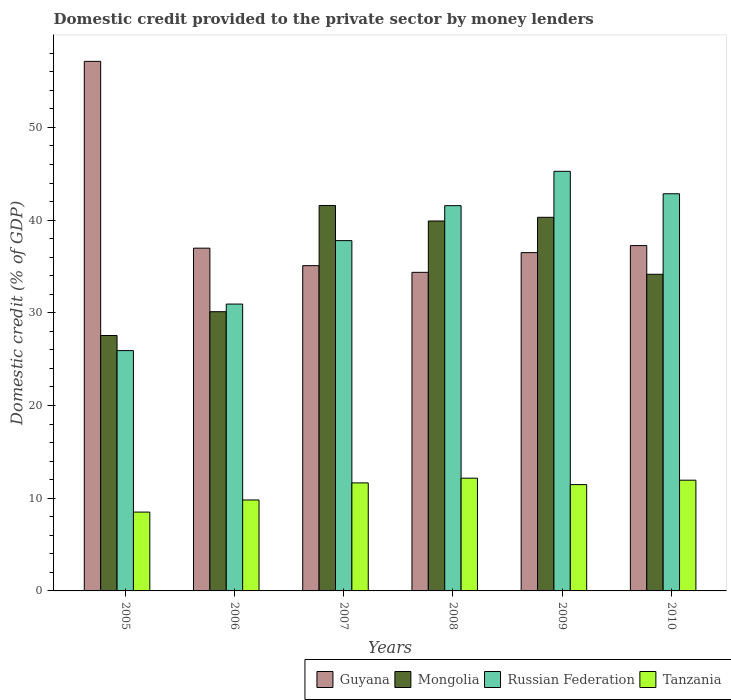Are the number of bars per tick equal to the number of legend labels?
Make the answer very short. Yes. Are the number of bars on each tick of the X-axis equal?
Give a very brief answer. Yes. What is the label of the 6th group of bars from the left?
Ensure brevity in your answer.  2010. What is the domestic credit provided to the private sector by money lenders in Mongolia in 2008?
Offer a very short reply. 39.9. Across all years, what is the maximum domestic credit provided to the private sector by money lenders in Mongolia?
Your response must be concise. 41.58. Across all years, what is the minimum domestic credit provided to the private sector by money lenders in Tanzania?
Your answer should be compact. 8.5. In which year was the domestic credit provided to the private sector by money lenders in Mongolia maximum?
Your answer should be compact. 2007. What is the total domestic credit provided to the private sector by money lenders in Russian Federation in the graph?
Offer a terse response. 224.3. What is the difference between the domestic credit provided to the private sector by money lenders in Tanzania in 2006 and that in 2009?
Make the answer very short. -1.66. What is the difference between the domestic credit provided to the private sector by money lenders in Guyana in 2008 and the domestic credit provided to the private sector by money lenders in Mongolia in 2005?
Offer a terse response. 6.81. What is the average domestic credit provided to the private sector by money lenders in Tanzania per year?
Give a very brief answer. 10.92. In the year 2007, what is the difference between the domestic credit provided to the private sector by money lenders in Russian Federation and domestic credit provided to the private sector by money lenders in Tanzania?
Give a very brief answer. 26.13. In how many years, is the domestic credit provided to the private sector by money lenders in Guyana greater than 10 %?
Give a very brief answer. 6. What is the ratio of the domestic credit provided to the private sector by money lenders in Russian Federation in 2008 to that in 2010?
Keep it short and to the point. 0.97. Is the domestic credit provided to the private sector by money lenders in Russian Federation in 2005 less than that in 2007?
Provide a succinct answer. Yes. What is the difference between the highest and the second highest domestic credit provided to the private sector by money lenders in Tanzania?
Provide a short and direct response. 0.22. What is the difference between the highest and the lowest domestic credit provided to the private sector by money lenders in Mongolia?
Ensure brevity in your answer.  14.03. In how many years, is the domestic credit provided to the private sector by money lenders in Guyana greater than the average domestic credit provided to the private sector by money lenders in Guyana taken over all years?
Your answer should be compact. 1. What does the 3rd bar from the left in 2010 represents?
Ensure brevity in your answer.  Russian Federation. What does the 1st bar from the right in 2008 represents?
Provide a succinct answer. Tanzania. How many bars are there?
Ensure brevity in your answer.  24. How many legend labels are there?
Offer a very short reply. 4. How are the legend labels stacked?
Your answer should be very brief. Horizontal. What is the title of the graph?
Provide a succinct answer. Domestic credit provided to the private sector by money lenders. Does "Armenia" appear as one of the legend labels in the graph?
Ensure brevity in your answer.  No. What is the label or title of the X-axis?
Make the answer very short. Years. What is the label or title of the Y-axis?
Offer a terse response. Domestic credit (% of GDP). What is the Domestic credit (% of GDP) of Guyana in 2005?
Your answer should be very brief. 57.12. What is the Domestic credit (% of GDP) in Mongolia in 2005?
Provide a short and direct response. 27.55. What is the Domestic credit (% of GDP) of Russian Federation in 2005?
Keep it short and to the point. 25.92. What is the Domestic credit (% of GDP) in Tanzania in 2005?
Provide a succinct answer. 8.5. What is the Domestic credit (% of GDP) of Guyana in 2006?
Give a very brief answer. 36.97. What is the Domestic credit (% of GDP) in Mongolia in 2006?
Offer a terse response. 30.12. What is the Domestic credit (% of GDP) in Russian Federation in 2006?
Provide a succinct answer. 30.94. What is the Domestic credit (% of GDP) of Tanzania in 2006?
Your answer should be compact. 9.81. What is the Domestic credit (% of GDP) of Guyana in 2007?
Ensure brevity in your answer.  35.08. What is the Domestic credit (% of GDP) of Mongolia in 2007?
Offer a terse response. 41.58. What is the Domestic credit (% of GDP) in Russian Federation in 2007?
Offer a terse response. 37.78. What is the Domestic credit (% of GDP) in Tanzania in 2007?
Your answer should be compact. 11.65. What is the Domestic credit (% of GDP) of Guyana in 2008?
Provide a short and direct response. 34.36. What is the Domestic credit (% of GDP) in Mongolia in 2008?
Provide a succinct answer. 39.9. What is the Domestic credit (% of GDP) in Russian Federation in 2008?
Ensure brevity in your answer.  41.55. What is the Domestic credit (% of GDP) in Tanzania in 2008?
Offer a very short reply. 12.16. What is the Domestic credit (% of GDP) in Guyana in 2009?
Keep it short and to the point. 36.49. What is the Domestic credit (% of GDP) of Mongolia in 2009?
Your response must be concise. 40.3. What is the Domestic credit (% of GDP) of Russian Federation in 2009?
Ensure brevity in your answer.  45.26. What is the Domestic credit (% of GDP) in Tanzania in 2009?
Keep it short and to the point. 11.47. What is the Domestic credit (% of GDP) of Guyana in 2010?
Your response must be concise. 37.25. What is the Domestic credit (% of GDP) in Mongolia in 2010?
Give a very brief answer. 34.16. What is the Domestic credit (% of GDP) in Russian Federation in 2010?
Your response must be concise. 42.84. What is the Domestic credit (% of GDP) in Tanzania in 2010?
Provide a succinct answer. 11.94. Across all years, what is the maximum Domestic credit (% of GDP) of Guyana?
Ensure brevity in your answer.  57.12. Across all years, what is the maximum Domestic credit (% of GDP) of Mongolia?
Keep it short and to the point. 41.58. Across all years, what is the maximum Domestic credit (% of GDP) in Russian Federation?
Keep it short and to the point. 45.26. Across all years, what is the maximum Domestic credit (% of GDP) in Tanzania?
Give a very brief answer. 12.16. Across all years, what is the minimum Domestic credit (% of GDP) in Guyana?
Offer a terse response. 34.36. Across all years, what is the minimum Domestic credit (% of GDP) in Mongolia?
Provide a short and direct response. 27.55. Across all years, what is the minimum Domestic credit (% of GDP) in Russian Federation?
Offer a terse response. 25.92. Across all years, what is the minimum Domestic credit (% of GDP) in Tanzania?
Make the answer very short. 8.5. What is the total Domestic credit (% of GDP) of Guyana in the graph?
Offer a very short reply. 237.28. What is the total Domestic credit (% of GDP) in Mongolia in the graph?
Provide a short and direct response. 213.6. What is the total Domestic credit (% of GDP) in Russian Federation in the graph?
Offer a terse response. 224.3. What is the total Domestic credit (% of GDP) in Tanzania in the graph?
Keep it short and to the point. 65.54. What is the difference between the Domestic credit (% of GDP) of Guyana in 2005 and that in 2006?
Offer a terse response. 20.15. What is the difference between the Domestic credit (% of GDP) of Mongolia in 2005 and that in 2006?
Give a very brief answer. -2.57. What is the difference between the Domestic credit (% of GDP) in Russian Federation in 2005 and that in 2006?
Offer a terse response. -5.02. What is the difference between the Domestic credit (% of GDP) in Tanzania in 2005 and that in 2006?
Give a very brief answer. -1.31. What is the difference between the Domestic credit (% of GDP) of Guyana in 2005 and that in 2007?
Offer a very short reply. 22.04. What is the difference between the Domestic credit (% of GDP) in Mongolia in 2005 and that in 2007?
Offer a very short reply. -14.03. What is the difference between the Domestic credit (% of GDP) in Russian Federation in 2005 and that in 2007?
Make the answer very short. -11.86. What is the difference between the Domestic credit (% of GDP) in Tanzania in 2005 and that in 2007?
Give a very brief answer. -3.15. What is the difference between the Domestic credit (% of GDP) of Guyana in 2005 and that in 2008?
Your response must be concise. 22.76. What is the difference between the Domestic credit (% of GDP) of Mongolia in 2005 and that in 2008?
Make the answer very short. -12.35. What is the difference between the Domestic credit (% of GDP) of Russian Federation in 2005 and that in 2008?
Give a very brief answer. -15.63. What is the difference between the Domestic credit (% of GDP) of Tanzania in 2005 and that in 2008?
Keep it short and to the point. -3.66. What is the difference between the Domestic credit (% of GDP) in Guyana in 2005 and that in 2009?
Your answer should be compact. 20.63. What is the difference between the Domestic credit (% of GDP) of Mongolia in 2005 and that in 2009?
Ensure brevity in your answer.  -12.75. What is the difference between the Domestic credit (% of GDP) in Russian Federation in 2005 and that in 2009?
Offer a terse response. -19.34. What is the difference between the Domestic credit (% of GDP) in Tanzania in 2005 and that in 2009?
Give a very brief answer. -2.96. What is the difference between the Domestic credit (% of GDP) of Guyana in 2005 and that in 2010?
Your answer should be very brief. 19.87. What is the difference between the Domestic credit (% of GDP) in Mongolia in 2005 and that in 2010?
Give a very brief answer. -6.61. What is the difference between the Domestic credit (% of GDP) of Russian Federation in 2005 and that in 2010?
Offer a terse response. -16.92. What is the difference between the Domestic credit (% of GDP) of Tanzania in 2005 and that in 2010?
Offer a terse response. -3.44. What is the difference between the Domestic credit (% of GDP) in Guyana in 2006 and that in 2007?
Your response must be concise. 1.89. What is the difference between the Domestic credit (% of GDP) in Mongolia in 2006 and that in 2007?
Your response must be concise. -11.46. What is the difference between the Domestic credit (% of GDP) of Russian Federation in 2006 and that in 2007?
Give a very brief answer. -6.84. What is the difference between the Domestic credit (% of GDP) in Tanzania in 2006 and that in 2007?
Offer a terse response. -1.84. What is the difference between the Domestic credit (% of GDP) of Guyana in 2006 and that in 2008?
Give a very brief answer. 2.61. What is the difference between the Domestic credit (% of GDP) in Mongolia in 2006 and that in 2008?
Make the answer very short. -9.78. What is the difference between the Domestic credit (% of GDP) of Russian Federation in 2006 and that in 2008?
Ensure brevity in your answer.  -10.61. What is the difference between the Domestic credit (% of GDP) of Tanzania in 2006 and that in 2008?
Your answer should be very brief. -2.35. What is the difference between the Domestic credit (% of GDP) in Guyana in 2006 and that in 2009?
Your answer should be very brief. 0.48. What is the difference between the Domestic credit (% of GDP) in Mongolia in 2006 and that in 2009?
Give a very brief answer. -10.18. What is the difference between the Domestic credit (% of GDP) of Russian Federation in 2006 and that in 2009?
Your response must be concise. -14.32. What is the difference between the Domestic credit (% of GDP) in Tanzania in 2006 and that in 2009?
Your response must be concise. -1.66. What is the difference between the Domestic credit (% of GDP) of Guyana in 2006 and that in 2010?
Your answer should be compact. -0.28. What is the difference between the Domestic credit (% of GDP) in Mongolia in 2006 and that in 2010?
Keep it short and to the point. -4.04. What is the difference between the Domestic credit (% of GDP) of Russian Federation in 2006 and that in 2010?
Ensure brevity in your answer.  -11.9. What is the difference between the Domestic credit (% of GDP) in Tanzania in 2006 and that in 2010?
Your response must be concise. -2.13. What is the difference between the Domestic credit (% of GDP) in Guyana in 2007 and that in 2008?
Offer a very short reply. 0.72. What is the difference between the Domestic credit (% of GDP) in Mongolia in 2007 and that in 2008?
Offer a very short reply. 1.67. What is the difference between the Domestic credit (% of GDP) in Russian Federation in 2007 and that in 2008?
Offer a terse response. -3.77. What is the difference between the Domestic credit (% of GDP) in Tanzania in 2007 and that in 2008?
Your answer should be very brief. -0.51. What is the difference between the Domestic credit (% of GDP) of Guyana in 2007 and that in 2009?
Your answer should be compact. -1.41. What is the difference between the Domestic credit (% of GDP) in Mongolia in 2007 and that in 2009?
Offer a terse response. 1.28. What is the difference between the Domestic credit (% of GDP) in Russian Federation in 2007 and that in 2009?
Give a very brief answer. -7.48. What is the difference between the Domestic credit (% of GDP) in Tanzania in 2007 and that in 2009?
Give a very brief answer. 0.18. What is the difference between the Domestic credit (% of GDP) of Guyana in 2007 and that in 2010?
Make the answer very short. -2.16. What is the difference between the Domestic credit (% of GDP) of Mongolia in 2007 and that in 2010?
Keep it short and to the point. 7.42. What is the difference between the Domestic credit (% of GDP) in Russian Federation in 2007 and that in 2010?
Make the answer very short. -5.06. What is the difference between the Domestic credit (% of GDP) of Tanzania in 2007 and that in 2010?
Give a very brief answer. -0.29. What is the difference between the Domestic credit (% of GDP) in Guyana in 2008 and that in 2009?
Ensure brevity in your answer.  -2.13. What is the difference between the Domestic credit (% of GDP) of Mongolia in 2008 and that in 2009?
Give a very brief answer. -0.4. What is the difference between the Domestic credit (% of GDP) of Russian Federation in 2008 and that in 2009?
Keep it short and to the point. -3.71. What is the difference between the Domestic credit (% of GDP) of Tanzania in 2008 and that in 2009?
Your answer should be very brief. 0.69. What is the difference between the Domestic credit (% of GDP) of Guyana in 2008 and that in 2010?
Keep it short and to the point. -2.88. What is the difference between the Domestic credit (% of GDP) of Mongolia in 2008 and that in 2010?
Keep it short and to the point. 5.75. What is the difference between the Domestic credit (% of GDP) of Russian Federation in 2008 and that in 2010?
Ensure brevity in your answer.  -1.29. What is the difference between the Domestic credit (% of GDP) of Tanzania in 2008 and that in 2010?
Give a very brief answer. 0.22. What is the difference between the Domestic credit (% of GDP) in Guyana in 2009 and that in 2010?
Your answer should be very brief. -0.76. What is the difference between the Domestic credit (% of GDP) of Mongolia in 2009 and that in 2010?
Offer a terse response. 6.14. What is the difference between the Domestic credit (% of GDP) in Russian Federation in 2009 and that in 2010?
Provide a short and direct response. 2.42. What is the difference between the Domestic credit (% of GDP) of Tanzania in 2009 and that in 2010?
Ensure brevity in your answer.  -0.48. What is the difference between the Domestic credit (% of GDP) in Guyana in 2005 and the Domestic credit (% of GDP) in Mongolia in 2006?
Offer a very short reply. 27. What is the difference between the Domestic credit (% of GDP) of Guyana in 2005 and the Domestic credit (% of GDP) of Russian Federation in 2006?
Offer a very short reply. 26.18. What is the difference between the Domestic credit (% of GDP) of Guyana in 2005 and the Domestic credit (% of GDP) of Tanzania in 2006?
Your response must be concise. 47.31. What is the difference between the Domestic credit (% of GDP) of Mongolia in 2005 and the Domestic credit (% of GDP) of Russian Federation in 2006?
Your answer should be very brief. -3.39. What is the difference between the Domestic credit (% of GDP) of Mongolia in 2005 and the Domestic credit (% of GDP) of Tanzania in 2006?
Provide a succinct answer. 17.74. What is the difference between the Domestic credit (% of GDP) in Russian Federation in 2005 and the Domestic credit (% of GDP) in Tanzania in 2006?
Provide a succinct answer. 16.11. What is the difference between the Domestic credit (% of GDP) in Guyana in 2005 and the Domestic credit (% of GDP) in Mongolia in 2007?
Your answer should be very brief. 15.55. What is the difference between the Domestic credit (% of GDP) in Guyana in 2005 and the Domestic credit (% of GDP) in Russian Federation in 2007?
Your answer should be compact. 19.34. What is the difference between the Domestic credit (% of GDP) in Guyana in 2005 and the Domestic credit (% of GDP) in Tanzania in 2007?
Your response must be concise. 45.47. What is the difference between the Domestic credit (% of GDP) in Mongolia in 2005 and the Domestic credit (% of GDP) in Russian Federation in 2007?
Give a very brief answer. -10.23. What is the difference between the Domestic credit (% of GDP) in Mongolia in 2005 and the Domestic credit (% of GDP) in Tanzania in 2007?
Offer a terse response. 15.9. What is the difference between the Domestic credit (% of GDP) of Russian Federation in 2005 and the Domestic credit (% of GDP) of Tanzania in 2007?
Offer a terse response. 14.27. What is the difference between the Domestic credit (% of GDP) of Guyana in 2005 and the Domestic credit (% of GDP) of Mongolia in 2008?
Give a very brief answer. 17.22. What is the difference between the Domestic credit (% of GDP) in Guyana in 2005 and the Domestic credit (% of GDP) in Russian Federation in 2008?
Offer a terse response. 15.57. What is the difference between the Domestic credit (% of GDP) of Guyana in 2005 and the Domestic credit (% of GDP) of Tanzania in 2008?
Your answer should be very brief. 44.96. What is the difference between the Domestic credit (% of GDP) of Mongolia in 2005 and the Domestic credit (% of GDP) of Russian Federation in 2008?
Your answer should be compact. -14. What is the difference between the Domestic credit (% of GDP) of Mongolia in 2005 and the Domestic credit (% of GDP) of Tanzania in 2008?
Ensure brevity in your answer.  15.39. What is the difference between the Domestic credit (% of GDP) in Russian Federation in 2005 and the Domestic credit (% of GDP) in Tanzania in 2008?
Offer a terse response. 13.76. What is the difference between the Domestic credit (% of GDP) in Guyana in 2005 and the Domestic credit (% of GDP) in Mongolia in 2009?
Ensure brevity in your answer.  16.82. What is the difference between the Domestic credit (% of GDP) of Guyana in 2005 and the Domestic credit (% of GDP) of Russian Federation in 2009?
Offer a terse response. 11.86. What is the difference between the Domestic credit (% of GDP) in Guyana in 2005 and the Domestic credit (% of GDP) in Tanzania in 2009?
Make the answer very short. 45.65. What is the difference between the Domestic credit (% of GDP) in Mongolia in 2005 and the Domestic credit (% of GDP) in Russian Federation in 2009?
Make the answer very short. -17.71. What is the difference between the Domestic credit (% of GDP) of Mongolia in 2005 and the Domestic credit (% of GDP) of Tanzania in 2009?
Keep it short and to the point. 16.08. What is the difference between the Domestic credit (% of GDP) of Russian Federation in 2005 and the Domestic credit (% of GDP) of Tanzania in 2009?
Offer a terse response. 14.46. What is the difference between the Domestic credit (% of GDP) of Guyana in 2005 and the Domestic credit (% of GDP) of Mongolia in 2010?
Offer a very short reply. 22.97. What is the difference between the Domestic credit (% of GDP) of Guyana in 2005 and the Domestic credit (% of GDP) of Russian Federation in 2010?
Give a very brief answer. 14.28. What is the difference between the Domestic credit (% of GDP) of Guyana in 2005 and the Domestic credit (% of GDP) of Tanzania in 2010?
Provide a short and direct response. 45.18. What is the difference between the Domestic credit (% of GDP) of Mongolia in 2005 and the Domestic credit (% of GDP) of Russian Federation in 2010?
Your answer should be very brief. -15.29. What is the difference between the Domestic credit (% of GDP) in Mongolia in 2005 and the Domestic credit (% of GDP) in Tanzania in 2010?
Provide a short and direct response. 15.61. What is the difference between the Domestic credit (% of GDP) in Russian Federation in 2005 and the Domestic credit (% of GDP) in Tanzania in 2010?
Your answer should be compact. 13.98. What is the difference between the Domestic credit (% of GDP) in Guyana in 2006 and the Domestic credit (% of GDP) in Mongolia in 2007?
Offer a very short reply. -4.6. What is the difference between the Domestic credit (% of GDP) of Guyana in 2006 and the Domestic credit (% of GDP) of Russian Federation in 2007?
Your answer should be very brief. -0.81. What is the difference between the Domestic credit (% of GDP) in Guyana in 2006 and the Domestic credit (% of GDP) in Tanzania in 2007?
Your response must be concise. 25.32. What is the difference between the Domestic credit (% of GDP) in Mongolia in 2006 and the Domestic credit (% of GDP) in Russian Federation in 2007?
Make the answer very short. -7.66. What is the difference between the Domestic credit (% of GDP) of Mongolia in 2006 and the Domestic credit (% of GDP) of Tanzania in 2007?
Make the answer very short. 18.47. What is the difference between the Domestic credit (% of GDP) in Russian Federation in 2006 and the Domestic credit (% of GDP) in Tanzania in 2007?
Offer a terse response. 19.29. What is the difference between the Domestic credit (% of GDP) of Guyana in 2006 and the Domestic credit (% of GDP) of Mongolia in 2008?
Your answer should be compact. -2.93. What is the difference between the Domestic credit (% of GDP) of Guyana in 2006 and the Domestic credit (% of GDP) of Russian Federation in 2008?
Ensure brevity in your answer.  -4.58. What is the difference between the Domestic credit (% of GDP) of Guyana in 2006 and the Domestic credit (% of GDP) of Tanzania in 2008?
Your answer should be very brief. 24.81. What is the difference between the Domestic credit (% of GDP) in Mongolia in 2006 and the Domestic credit (% of GDP) in Russian Federation in 2008?
Give a very brief answer. -11.44. What is the difference between the Domestic credit (% of GDP) in Mongolia in 2006 and the Domestic credit (% of GDP) in Tanzania in 2008?
Your response must be concise. 17.96. What is the difference between the Domestic credit (% of GDP) in Russian Federation in 2006 and the Domestic credit (% of GDP) in Tanzania in 2008?
Provide a short and direct response. 18.78. What is the difference between the Domestic credit (% of GDP) of Guyana in 2006 and the Domestic credit (% of GDP) of Mongolia in 2009?
Your response must be concise. -3.33. What is the difference between the Domestic credit (% of GDP) in Guyana in 2006 and the Domestic credit (% of GDP) in Russian Federation in 2009?
Give a very brief answer. -8.29. What is the difference between the Domestic credit (% of GDP) of Guyana in 2006 and the Domestic credit (% of GDP) of Tanzania in 2009?
Your answer should be compact. 25.5. What is the difference between the Domestic credit (% of GDP) of Mongolia in 2006 and the Domestic credit (% of GDP) of Russian Federation in 2009?
Offer a very short reply. -15.14. What is the difference between the Domestic credit (% of GDP) of Mongolia in 2006 and the Domestic credit (% of GDP) of Tanzania in 2009?
Keep it short and to the point. 18.65. What is the difference between the Domestic credit (% of GDP) of Russian Federation in 2006 and the Domestic credit (% of GDP) of Tanzania in 2009?
Your answer should be very brief. 19.47. What is the difference between the Domestic credit (% of GDP) of Guyana in 2006 and the Domestic credit (% of GDP) of Mongolia in 2010?
Offer a terse response. 2.82. What is the difference between the Domestic credit (% of GDP) of Guyana in 2006 and the Domestic credit (% of GDP) of Russian Federation in 2010?
Provide a short and direct response. -5.87. What is the difference between the Domestic credit (% of GDP) of Guyana in 2006 and the Domestic credit (% of GDP) of Tanzania in 2010?
Ensure brevity in your answer.  25.03. What is the difference between the Domestic credit (% of GDP) of Mongolia in 2006 and the Domestic credit (% of GDP) of Russian Federation in 2010?
Your answer should be compact. -12.72. What is the difference between the Domestic credit (% of GDP) in Mongolia in 2006 and the Domestic credit (% of GDP) in Tanzania in 2010?
Provide a succinct answer. 18.18. What is the difference between the Domestic credit (% of GDP) of Russian Federation in 2006 and the Domestic credit (% of GDP) of Tanzania in 2010?
Your answer should be compact. 19. What is the difference between the Domestic credit (% of GDP) in Guyana in 2007 and the Domestic credit (% of GDP) in Mongolia in 2008?
Provide a succinct answer. -4.82. What is the difference between the Domestic credit (% of GDP) in Guyana in 2007 and the Domestic credit (% of GDP) in Russian Federation in 2008?
Provide a short and direct response. -6.47. What is the difference between the Domestic credit (% of GDP) of Guyana in 2007 and the Domestic credit (% of GDP) of Tanzania in 2008?
Your answer should be very brief. 22.92. What is the difference between the Domestic credit (% of GDP) of Mongolia in 2007 and the Domestic credit (% of GDP) of Russian Federation in 2008?
Offer a terse response. 0.02. What is the difference between the Domestic credit (% of GDP) of Mongolia in 2007 and the Domestic credit (% of GDP) of Tanzania in 2008?
Make the answer very short. 29.42. What is the difference between the Domestic credit (% of GDP) of Russian Federation in 2007 and the Domestic credit (% of GDP) of Tanzania in 2008?
Provide a succinct answer. 25.62. What is the difference between the Domestic credit (% of GDP) of Guyana in 2007 and the Domestic credit (% of GDP) of Mongolia in 2009?
Your answer should be very brief. -5.22. What is the difference between the Domestic credit (% of GDP) of Guyana in 2007 and the Domestic credit (% of GDP) of Russian Federation in 2009?
Provide a succinct answer. -10.18. What is the difference between the Domestic credit (% of GDP) of Guyana in 2007 and the Domestic credit (% of GDP) of Tanzania in 2009?
Offer a very short reply. 23.62. What is the difference between the Domestic credit (% of GDP) in Mongolia in 2007 and the Domestic credit (% of GDP) in Russian Federation in 2009?
Offer a very short reply. -3.68. What is the difference between the Domestic credit (% of GDP) of Mongolia in 2007 and the Domestic credit (% of GDP) of Tanzania in 2009?
Provide a short and direct response. 30.11. What is the difference between the Domestic credit (% of GDP) of Russian Federation in 2007 and the Domestic credit (% of GDP) of Tanzania in 2009?
Offer a very short reply. 26.32. What is the difference between the Domestic credit (% of GDP) in Guyana in 2007 and the Domestic credit (% of GDP) in Mongolia in 2010?
Your answer should be compact. 0.93. What is the difference between the Domestic credit (% of GDP) of Guyana in 2007 and the Domestic credit (% of GDP) of Russian Federation in 2010?
Ensure brevity in your answer.  -7.76. What is the difference between the Domestic credit (% of GDP) of Guyana in 2007 and the Domestic credit (% of GDP) of Tanzania in 2010?
Make the answer very short. 23.14. What is the difference between the Domestic credit (% of GDP) of Mongolia in 2007 and the Domestic credit (% of GDP) of Russian Federation in 2010?
Your answer should be compact. -1.26. What is the difference between the Domestic credit (% of GDP) in Mongolia in 2007 and the Domestic credit (% of GDP) in Tanzania in 2010?
Your answer should be compact. 29.63. What is the difference between the Domestic credit (% of GDP) of Russian Federation in 2007 and the Domestic credit (% of GDP) of Tanzania in 2010?
Provide a short and direct response. 25.84. What is the difference between the Domestic credit (% of GDP) in Guyana in 2008 and the Domestic credit (% of GDP) in Mongolia in 2009?
Ensure brevity in your answer.  -5.94. What is the difference between the Domestic credit (% of GDP) in Guyana in 2008 and the Domestic credit (% of GDP) in Russian Federation in 2009?
Your answer should be very brief. -10.9. What is the difference between the Domestic credit (% of GDP) of Guyana in 2008 and the Domestic credit (% of GDP) of Tanzania in 2009?
Your answer should be very brief. 22.9. What is the difference between the Domestic credit (% of GDP) of Mongolia in 2008 and the Domestic credit (% of GDP) of Russian Federation in 2009?
Provide a short and direct response. -5.36. What is the difference between the Domestic credit (% of GDP) in Mongolia in 2008 and the Domestic credit (% of GDP) in Tanzania in 2009?
Provide a succinct answer. 28.43. What is the difference between the Domestic credit (% of GDP) in Russian Federation in 2008 and the Domestic credit (% of GDP) in Tanzania in 2009?
Make the answer very short. 30.09. What is the difference between the Domestic credit (% of GDP) of Guyana in 2008 and the Domestic credit (% of GDP) of Mongolia in 2010?
Provide a succinct answer. 0.21. What is the difference between the Domestic credit (% of GDP) of Guyana in 2008 and the Domestic credit (% of GDP) of Russian Federation in 2010?
Your answer should be compact. -8.48. What is the difference between the Domestic credit (% of GDP) in Guyana in 2008 and the Domestic credit (% of GDP) in Tanzania in 2010?
Provide a short and direct response. 22.42. What is the difference between the Domestic credit (% of GDP) of Mongolia in 2008 and the Domestic credit (% of GDP) of Russian Federation in 2010?
Provide a succinct answer. -2.94. What is the difference between the Domestic credit (% of GDP) in Mongolia in 2008 and the Domestic credit (% of GDP) in Tanzania in 2010?
Keep it short and to the point. 27.96. What is the difference between the Domestic credit (% of GDP) in Russian Federation in 2008 and the Domestic credit (% of GDP) in Tanzania in 2010?
Your answer should be compact. 29.61. What is the difference between the Domestic credit (% of GDP) in Guyana in 2009 and the Domestic credit (% of GDP) in Mongolia in 2010?
Your response must be concise. 2.33. What is the difference between the Domestic credit (% of GDP) of Guyana in 2009 and the Domestic credit (% of GDP) of Russian Federation in 2010?
Offer a terse response. -6.35. What is the difference between the Domestic credit (% of GDP) in Guyana in 2009 and the Domestic credit (% of GDP) in Tanzania in 2010?
Offer a terse response. 24.55. What is the difference between the Domestic credit (% of GDP) of Mongolia in 2009 and the Domestic credit (% of GDP) of Russian Federation in 2010?
Provide a succinct answer. -2.54. What is the difference between the Domestic credit (% of GDP) in Mongolia in 2009 and the Domestic credit (% of GDP) in Tanzania in 2010?
Provide a short and direct response. 28.36. What is the difference between the Domestic credit (% of GDP) in Russian Federation in 2009 and the Domestic credit (% of GDP) in Tanzania in 2010?
Your answer should be very brief. 33.32. What is the average Domestic credit (% of GDP) in Guyana per year?
Provide a short and direct response. 39.55. What is the average Domestic credit (% of GDP) of Mongolia per year?
Your answer should be very brief. 35.6. What is the average Domestic credit (% of GDP) in Russian Federation per year?
Keep it short and to the point. 37.38. What is the average Domestic credit (% of GDP) of Tanzania per year?
Provide a succinct answer. 10.92. In the year 2005, what is the difference between the Domestic credit (% of GDP) in Guyana and Domestic credit (% of GDP) in Mongolia?
Make the answer very short. 29.57. In the year 2005, what is the difference between the Domestic credit (% of GDP) of Guyana and Domestic credit (% of GDP) of Russian Federation?
Offer a terse response. 31.2. In the year 2005, what is the difference between the Domestic credit (% of GDP) of Guyana and Domestic credit (% of GDP) of Tanzania?
Provide a succinct answer. 48.62. In the year 2005, what is the difference between the Domestic credit (% of GDP) of Mongolia and Domestic credit (% of GDP) of Russian Federation?
Ensure brevity in your answer.  1.63. In the year 2005, what is the difference between the Domestic credit (% of GDP) in Mongolia and Domestic credit (% of GDP) in Tanzania?
Give a very brief answer. 19.05. In the year 2005, what is the difference between the Domestic credit (% of GDP) in Russian Federation and Domestic credit (% of GDP) in Tanzania?
Make the answer very short. 17.42. In the year 2006, what is the difference between the Domestic credit (% of GDP) of Guyana and Domestic credit (% of GDP) of Mongolia?
Offer a terse response. 6.85. In the year 2006, what is the difference between the Domestic credit (% of GDP) in Guyana and Domestic credit (% of GDP) in Russian Federation?
Your answer should be very brief. 6.03. In the year 2006, what is the difference between the Domestic credit (% of GDP) in Guyana and Domestic credit (% of GDP) in Tanzania?
Give a very brief answer. 27.16. In the year 2006, what is the difference between the Domestic credit (% of GDP) in Mongolia and Domestic credit (% of GDP) in Russian Federation?
Keep it short and to the point. -0.82. In the year 2006, what is the difference between the Domestic credit (% of GDP) in Mongolia and Domestic credit (% of GDP) in Tanzania?
Give a very brief answer. 20.31. In the year 2006, what is the difference between the Domestic credit (% of GDP) in Russian Federation and Domestic credit (% of GDP) in Tanzania?
Provide a short and direct response. 21.13. In the year 2007, what is the difference between the Domestic credit (% of GDP) in Guyana and Domestic credit (% of GDP) in Mongolia?
Offer a terse response. -6.49. In the year 2007, what is the difference between the Domestic credit (% of GDP) in Guyana and Domestic credit (% of GDP) in Tanzania?
Your answer should be compact. 23.43. In the year 2007, what is the difference between the Domestic credit (% of GDP) of Mongolia and Domestic credit (% of GDP) of Russian Federation?
Offer a terse response. 3.79. In the year 2007, what is the difference between the Domestic credit (% of GDP) of Mongolia and Domestic credit (% of GDP) of Tanzania?
Provide a short and direct response. 29.93. In the year 2007, what is the difference between the Domestic credit (% of GDP) of Russian Federation and Domestic credit (% of GDP) of Tanzania?
Offer a terse response. 26.13. In the year 2008, what is the difference between the Domestic credit (% of GDP) in Guyana and Domestic credit (% of GDP) in Mongolia?
Provide a succinct answer. -5.54. In the year 2008, what is the difference between the Domestic credit (% of GDP) of Guyana and Domestic credit (% of GDP) of Russian Federation?
Provide a succinct answer. -7.19. In the year 2008, what is the difference between the Domestic credit (% of GDP) of Guyana and Domestic credit (% of GDP) of Tanzania?
Offer a terse response. 22.2. In the year 2008, what is the difference between the Domestic credit (% of GDP) of Mongolia and Domestic credit (% of GDP) of Russian Federation?
Provide a short and direct response. -1.65. In the year 2008, what is the difference between the Domestic credit (% of GDP) in Mongolia and Domestic credit (% of GDP) in Tanzania?
Offer a very short reply. 27.74. In the year 2008, what is the difference between the Domestic credit (% of GDP) of Russian Federation and Domestic credit (% of GDP) of Tanzania?
Offer a very short reply. 29.39. In the year 2009, what is the difference between the Domestic credit (% of GDP) of Guyana and Domestic credit (% of GDP) of Mongolia?
Your response must be concise. -3.81. In the year 2009, what is the difference between the Domestic credit (% of GDP) in Guyana and Domestic credit (% of GDP) in Russian Federation?
Provide a short and direct response. -8.77. In the year 2009, what is the difference between the Domestic credit (% of GDP) in Guyana and Domestic credit (% of GDP) in Tanzania?
Make the answer very short. 25.02. In the year 2009, what is the difference between the Domestic credit (% of GDP) of Mongolia and Domestic credit (% of GDP) of Russian Federation?
Your answer should be compact. -4.96. In the year 2009, what is the difference between the Domestic credit (% of GDP) of Mongolia and Domestic credit (% of GDP) of Tanzania?
Your answer should be very brief. 28.83. In the year 2009, what is the difference between the Domestic credit (% of GDP) of Russian Federation and Domestic credit (% of GDP) of Tanzania?
Your response must be concise. 33.79. In the year 2010, what is the difference between the Domestic credit (% of GDP) of Guyana and Domestic credit (% of GDP) of Mongolia?
Provide a short and direct response. 3.09. In the year 2010, what is the difference between the Domestic credit (% of GDP) in Guyana and Domestic credit (% of GDP) in Russian Federation?
Offer a very short reply. -5.59. In the year 2010, what is the difference between the Domestic credit (% of GDP) of Guyana and Domestic credit (% of GDP) of Tanzania?
Your answer should be very brief. 25.3. In the year 2010, what is the difference between the Domestic credit (% of GDP) in Mongolia and Domestic credit (% of GDP) in Russian Federation?
Keep it short and to the point. -8.68. In the year 2010, what is the difference between the Domestic credit (% of GDP) of Mongolia and Domestic credit (% of GDP) of Tanzania?
Provide a short and direct response. 22.21. In the year 2010, what is the difference between the Domestic credit (% of GDP) in Russian Federation and Domestic credit (% of GDP) in Tanzania?
Provide a short and direct response. 30.9. What is the ratio of the Domestic credit (% of GDP) in Guyana in 2005 to that in 2006?
Your answer should be compact. 1.54. What is the ratio of the Domestic credit (% of GDP) in Mongolia in 2005 to that in 2006?
Offer a terse response. 0.91. What is the ratio of the Domestic credit (% of GDP) in Russian Federation in 2005 to that in 2006?
Provide a succinct answer. 0.84. What is the ratio of the Domestic credit (% of GDP) of Tanzania in 2005 to that in 2006?
Keep it short and to the point. 0.87. What is the ratio of the Domestic credit (% of GDP) of Guyana in 2005 to that in 2007?
Provide a short and direct response. 1.63. What is the ratio of the Domestic credit (% of GDP) of Mongolia in 2005 to that in 2007?
Provide a succinct answer. 0.66. What is the ratio of the Domestic credit (% of GDP) in Russian Federation in 2005 to that in 2007?
Give a very brief answer. 0.69. What is the ratio of the Domestic credit (% of GDP) of Tanzania in 2005 to that in 2007?
Offer a terse response. 0.73. What is the ratio of the Domestic credit (% of GDP) of Guyana in 2005 to that in 2008?
Provide a succinct answer. 1.66. What is the ratio of the Domestic credit (% of GDP) in Mongolia in 2005 to that in 2008?
Offer a very short reply. 0.69. What is the ratio of the Domestic credit (% of GDP) of Russian Federation in 2005 to that in 2008?
Make the answer very short. 0.62. What is the ratio of the Domestic credit (% of GDP) of Tanzania in 2005 to that in 2008?
Make the answer very short. 0.7. What is the ratio of the Domestic credit (% of GDP) in Guyana in 2005 to that in 2009?
Provide a succinct answer. 1.57. What is the ratio of the Domestic credit (% of GDP) of Mongolia in 2005 to that in 2009?
Offer a terse response. 0.68. What is the ratio of the Domestic credit (% of GDP) of Russian Federation in 2005 to that in 2009?
Your answer should be compact. 0.57. What is the ratio of the Domestic credit (% of GDP) of Tanzania in 2005 to that in 2009?
Offer a very short reply. 0.74. What is the ratio of the Domestic credit (% of GDP) of Guyana in 2005 to that in 2010?
Your answer should be very brief. 1.53. What is the ratio of the Domestic credit (% of GDP) of Mongolia in 2005 to that in 2010?
Give a very brief answer. 0.81. What is the ratio of the Domestic credit (% of GDP) in Russian Federation in 2005 to that in 2010?
Offer a terse response. 0.61. What is the ratio of the Domestic credit (% of GDP) of Tanzania in 2005 to that in 2010?
Offer a very short reply. 0.71. What is the ratio of the Domestic credit (% of GDP) in Guyana in 2006 to that in 2007?
Provide a succinct answer. 1.05. What is the ratio of the Domestic credit (% of GDP) in Mongolia in 2006 to that in 2007?
Provide a short and direct response. 0.72. What is the ratio of the Domestic credit (% of GDP) in Russian Federation in 2006 to that in 2007?
Make the answer very short. 0.82. What is the ratio of the Domestic credit (% of GDP) in Tanzania in 2006 to that in 2007?
Offer a very short reply. 0.84. What is the ratio of the Domestic credit (% of GDP) in Guyana in 2006 to that in 2008?
Ensure brevity in your answer.  1.08. What is the ratio of the Domestic credit (% of GDP) in Mongolia in 2006 to that in 2008?
Keep it short and to the point. 0.75. What is the ratio of the Domestic credit (% of GDP) of Russian Federation in 2006 to that in 2008?
Offer a very short reply. 0.74. What is the ratio of the Domestic credit (% of GDP) of Tanzania in 2006 to that in 2008?
Ensure brevity in your answer.  0.81. What is the ratio of the Domestic credit (% of GDP) of Guyana in 2006 to that in 2009?
Your answer should be very brief. 1.01. What is the ratio of the Domestic credit (% of GDP) of Mongolia in 2006 to that in 2009?
Offer a terse response. 0.75. What is the ratio of the Domestic credit (% of GDP) in Russian Federation in 2006 to that in 2009?
Your response must be concise. 0.68. What is the ratio of the Domestic credit (% of GDP) in Tanzania in 2006 to that in 2009?
Your response must be concise. 0.86. What is the ratio of the Domestic credit (% of GDP) of Guyana in 2006 to that in 2010?
Provide a succinct answer. 0.99. What is the ratio of the Domestic credit (% of GDP) of Mongolia in 2006 to that in 2010?
Give a very brief answer. 0.88. What is the ratio of the Domestic credit (% of GDP) in Russian Federation in 2006 to that in 2010?
Give a very brief answer. 0.72. What is the ratio of the Domestic credit (% of GDP) in Tanzania in 2006 to that in 2010?
Keep it short and to the point. 0.82. What is the ratio of the Domestic credit (% of GDP) of Guyana in 2007 to that in 2008?
Your answer should be very brief. 1.02. What is the ratio of the Domestic credit (% of GDP) in Mongolia in 2007 to that in 2008?
Make the answer very short. 1.04. What is the ratio of the Domestic credit (% of GDP) of Russian Federation in 2007 to that in 2008?
Your answer should be compact. 0.91. What is the ratio of the Domestic credit (% of GDP) of Tanzania in 2007 to that in 2008?
Keep it short and to the point. 0.96. What is the ratio of the Domestic credit (% of GDP) in Guyana in 2007 to that in 2009?
Make the answer very short. 0.96. What is the ratio of the Domestic credit (% of GDP) in Mongolia in 2007 to that in 2009?
Your response must be concise. 1.03. What is the ratio of the Domestic credit (% of GDP) in Russian Federation in 2007 to that in 2009?
Your answer should be compact. 0.83. What is the ratio of the Domestic credit (% of GDP) in Tanzania in 2007 to that in 2009?
Your answer should be very brief. 1.02. What is the ratio of the Domestic credit (% of GDP) of Guyana in 2007 to that in 2010?
Your answer should be very brief. 0.94. What is the ratio of the Domestic credit (% of GDP) of Mongolia in 2007 to that in 2010?
Your answer should be very brief. 1.22. What is the ratio of the Domestic credit (% of GDP) of Russian Federation in 2007 to that in 2010?
Give a very brief answer. 0.88. What is the ratio of the Domestic credit (% of GDP) of Tanzania in 2007 to that in 2010?
Provide a succinct answer. 0.98. What is the ratio of the Domestic credit (% of GDP) of Guyana in 2008 to that in 2009?
Provide a succinct answer. 0.94. What is the ratio of the Domestic credit (% of GDP) in Russian Federation in 2008 to that in 2009?
Your answer should be compact. 0.92. What is the ratio of the Domestic credit (% of GDP) in Tanzania in 2008 to that in 2009?
Provide a short and direct response. 1.06. What is the ratio of the Domestic credit (% of GDP) in Guyana in 2008 to that in 2010?
Your answer should be compact. 0.92. What is the ratio of the Domestic credit (% of GDP) of Mongolia in 2008 to that in 2010?
Your response must be concise. 1.17. What is the ratio of the Domestic credit (% of GDP) in Russian Federation in 2008 to that in 2010?
Offer a terse response. 0.97. What is the ratio of the Domestic credit (% of GDP) of Tanzania in 2008 to that in 2010?
Ensure brevity in your answer.  1.02. What is the ratio of the Domestic credit (% of GDP) in Guyana in 2009 to that in 2010?
Your answer should be compact. 0.98. What is the ratio of the Domestic credit (% of GDP) of Mongolia in 2009 to that in 2010?
Your answer should be compact. 1.18. What is the ratio of the Domestic credit (% of GDP) in Russian Federation in 2009 to that in 2010?
Offer a very short reply. 1.06. What is the ratio of the Domestic credit (% of GDP) in Tanzania in 2009 to that in 2010?
Your response must be concise. 0.96. What is the difference between the highest and the second highest Domestic credit (% of GDP) in Guyana?
Provide a succinct answer. 19.87. What is the difference between the highest and the second highest Domestic credit (% of GDP) of Mongolia?
Offer a terse response. 1.28. What is the difference between the highest and the second highest Domestic credit (% of GDP) of Russian Federation?
Give a very brief answer. 2.42. What is the difference between the highest and the second highest Domestic credit (% of GDP) in Tanzania?
Make the answer very short. 0.22. What is the difference between the highest and the lowest Domestic credit (% of GDP) of Guyana?
Provide a succinct answer. 22.76. What is the difference between the highest and the lowest Domestic credit (% of GDP) in Mongolia?
Provide a short and direct response. 14.03. What is the difference between the highest and the lowest Domestic credit (% of GDP) in Russian Federation?
Keep it short and to the point. 19.34. What is the difference between the highest and the lowest Domestic credit (% of GDP) in Tanzania?
Offer a very short reply. 3.66. 